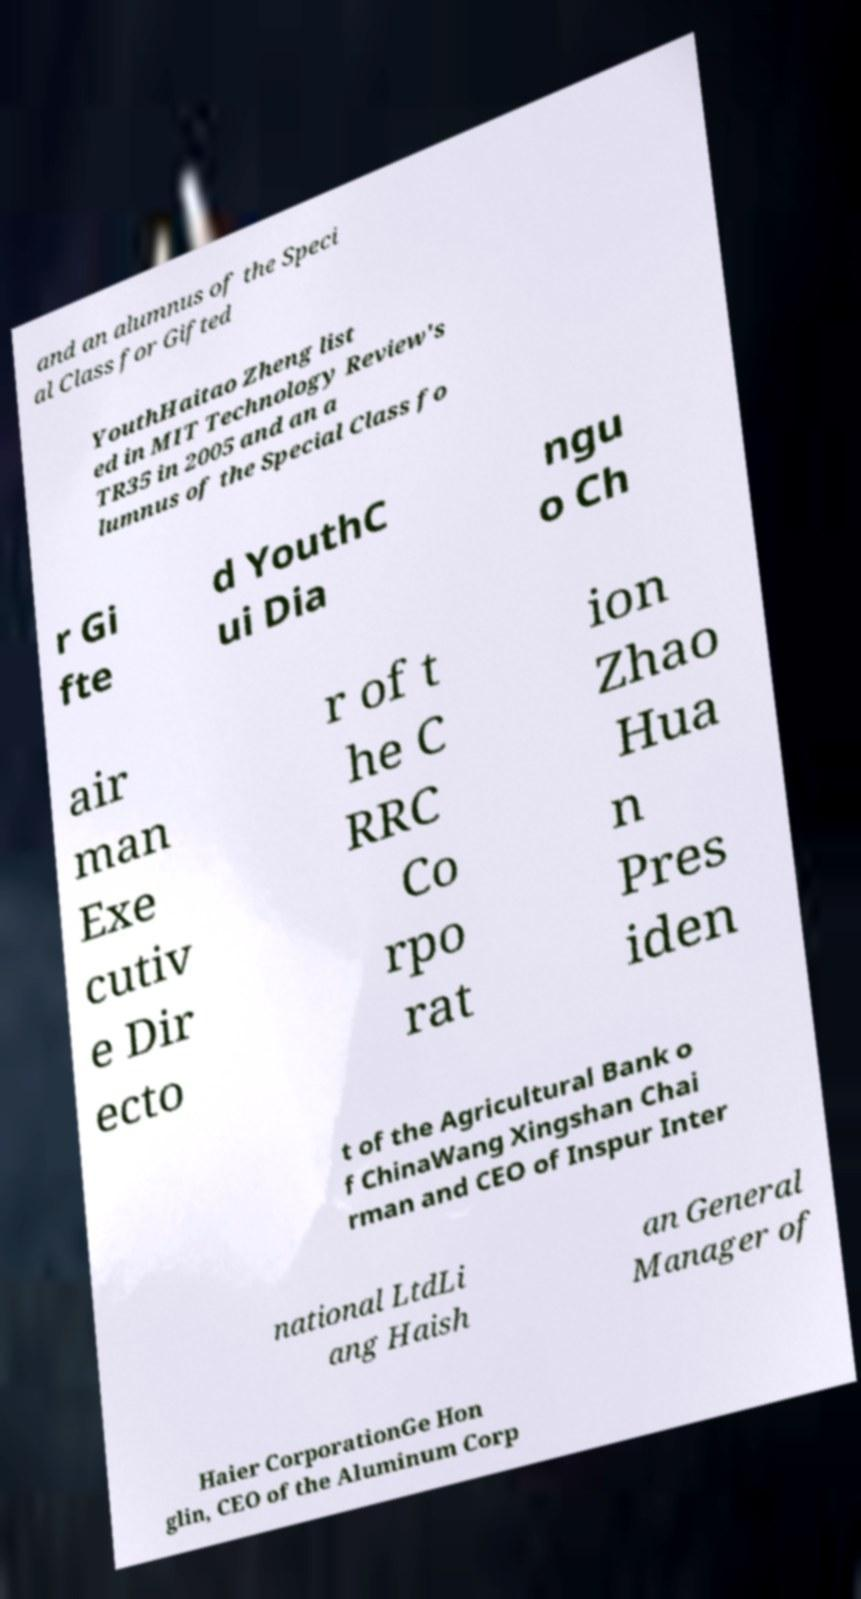Could you assist in decoding the text presented in this image and type it out clearly? and an alumnus of the Speci al Class for Gifted YouthHaitao Zheng list ed in MIT Technology Review's TR35 in 2005 and an a lumnus of the Special Class fo r Gi fte d YouthC ui Dia ngu o Ch air man Exe cutiv e Dir ecto r of t he C RRC Co rpo rat ion Zhao Hua n Pres iden t of the Agricultural Bank o f ChinaWang Xingshan Chai rman and CEO of Inspur Inter national LtdLi ang Haish an General Manager of Haier CorporationGe Hon glin, CEO of the Aluminum Corp 